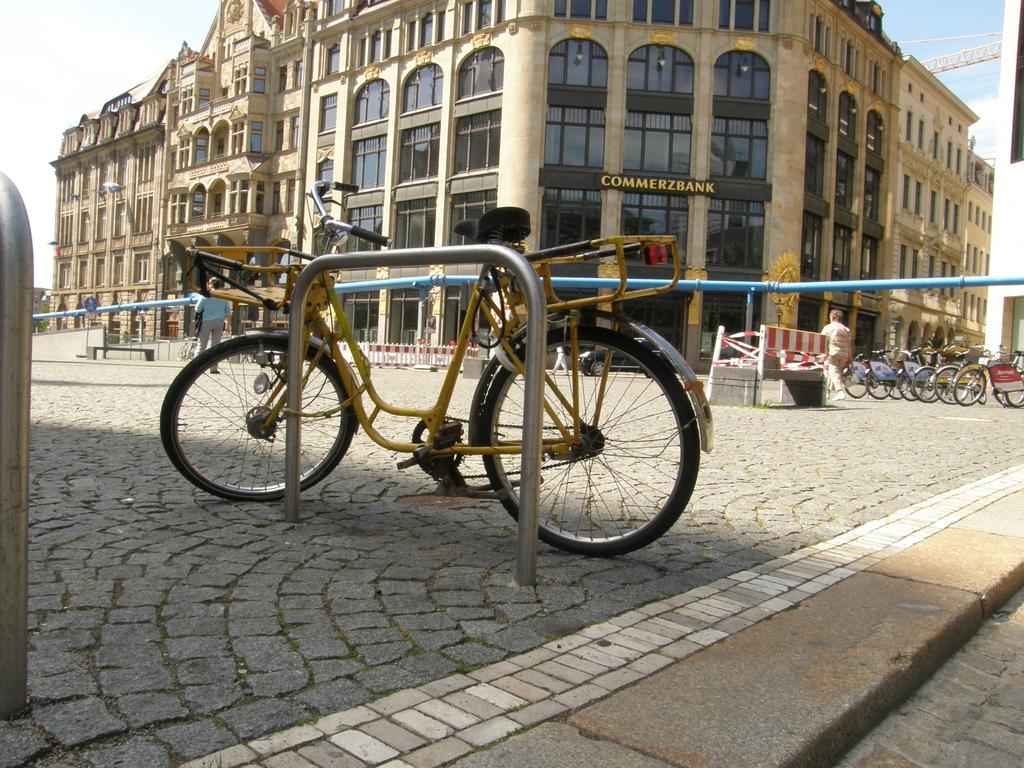What type of vehicles are in the image? There are bicycles in the image. What type of structure is visible in the image? There is a building with windows in the image. What part of the natural environment is visible in the image? The sky is visible in the image. How many jellyfish can be seen swimming in the sky in the image? There are no jellyfish present in the image, and therefore none can be seen swimming in the sky. 